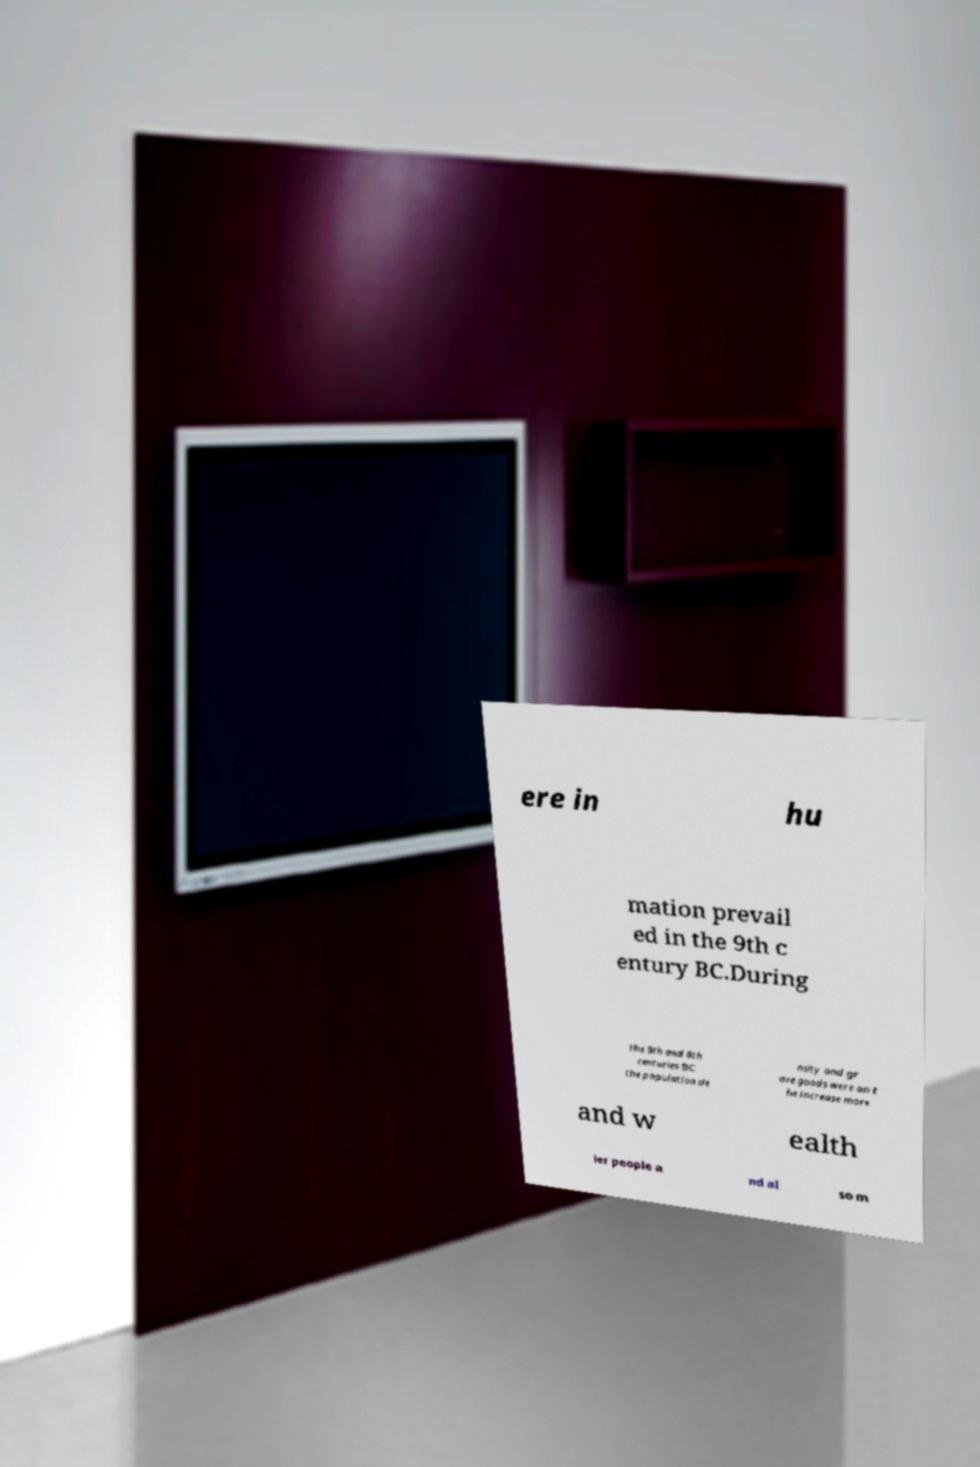There's text embedded in this image that I need extracted. Can you transcribe it verbatim? ere in hu mation prevail ed in the 9th c entury BC.During the 9th and 8th centuries BC the population de nsity and gr ave goods were on t he increase more and w ealth ier people a nd al so m 